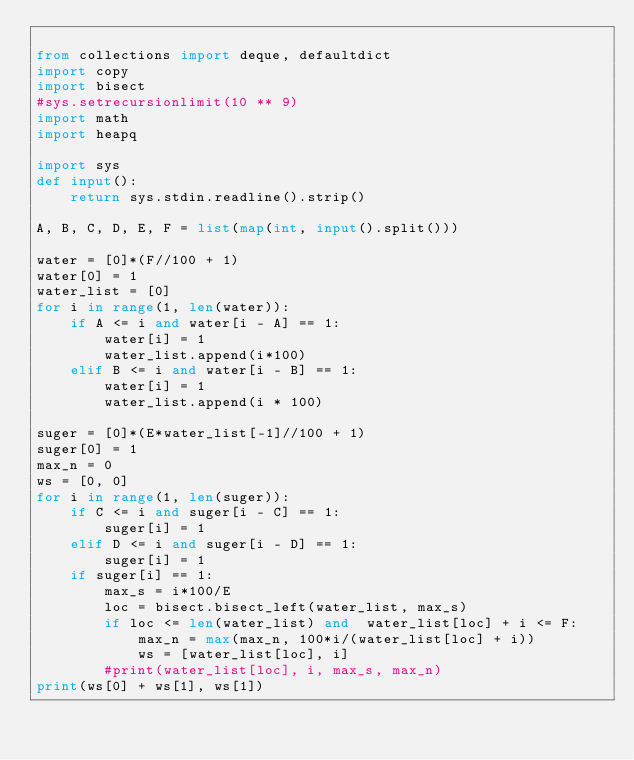Convert code to text. <code><loc_0><loc_0><loc_500><loc_500><_Python_>
from collections import deque, defaultdict
import copy
import bisect
#sys.setrecursionlimit(10 ** 9)
import math
import heapq

import sys
def input():
	return sys.stdin.readline().strip()

A, B, C, D, E, F = list(map(int, input().split()))

water = [0]*(F//100 + 1)
water[0] = 1
water_list = [0]
for i in range(1, len(water)):
	if A <= i and water[i - A] == 1:
		water[i] = 1
		water_list.append(i*100)
	elif B <= i and water[i - B] == 1:
		water[i] = 1
		water_list.append(i * 100)

suger = [0]*(E*water_list[-1]//100 + 1)
suger[0] = 1
max_n = 0
ws = [0, 0]
for i in range(1, len(suger)):
	if C <= i and suger[i - C] == 1:
		suger[i] = 1
	elif D <= i and suger[i - D] == 1:
		suger[i] = 1
	if suger[i] == 1:
		max_s = i*100/E
		loc = bisect.bisect_left(water_list, max_s)
		if loc <= len(water_list) and  water_list[loc] + i <= F:
			max_n = max(max_n, 100*i/(water_list[loc] + i))
			ws = [water_list[loc], i]
		#print(water_list[loc], i, max_s, max_n)
print(ws[0] + ws[1], ws[1])</code> 